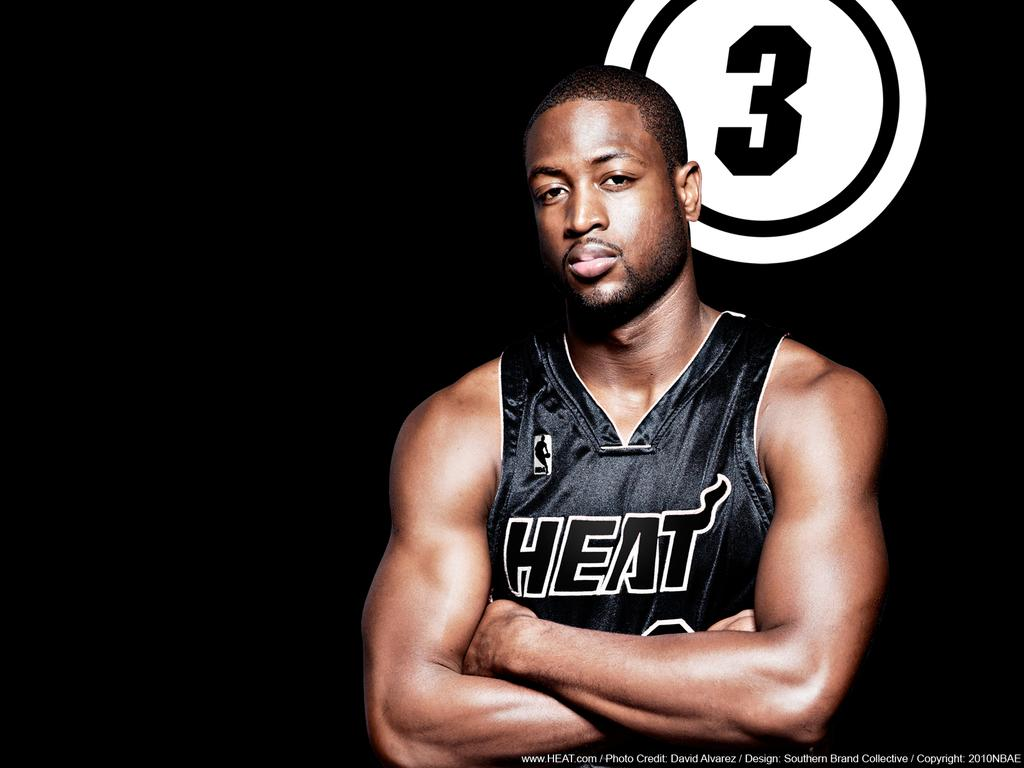<image>
Write a terse but informative summary of the picture. A guy in a Heat jersey is standing in front of the number 3. 